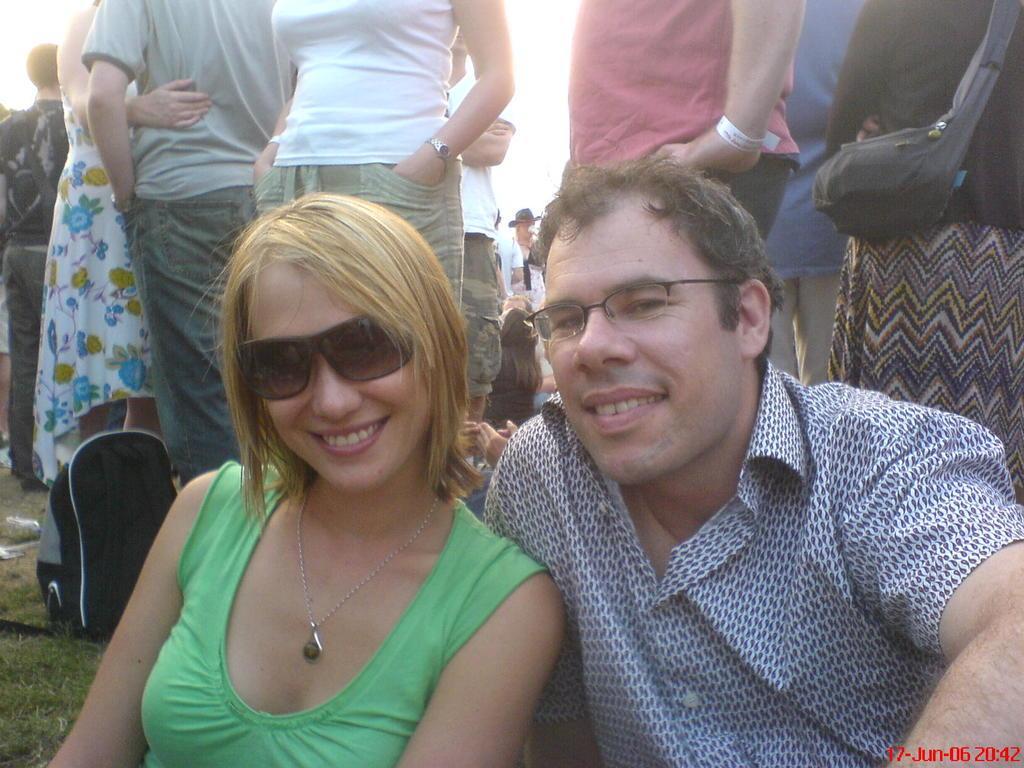Could you give a brief overview of what you see in this image? In this image we can see a group of people standing on the ground. One woman is wearing a green dress and goggles. One person wearing the shirt and spectacles. In the background, we can see a person carrying a bag ,and the sky, and a bag is placed on the ground. 